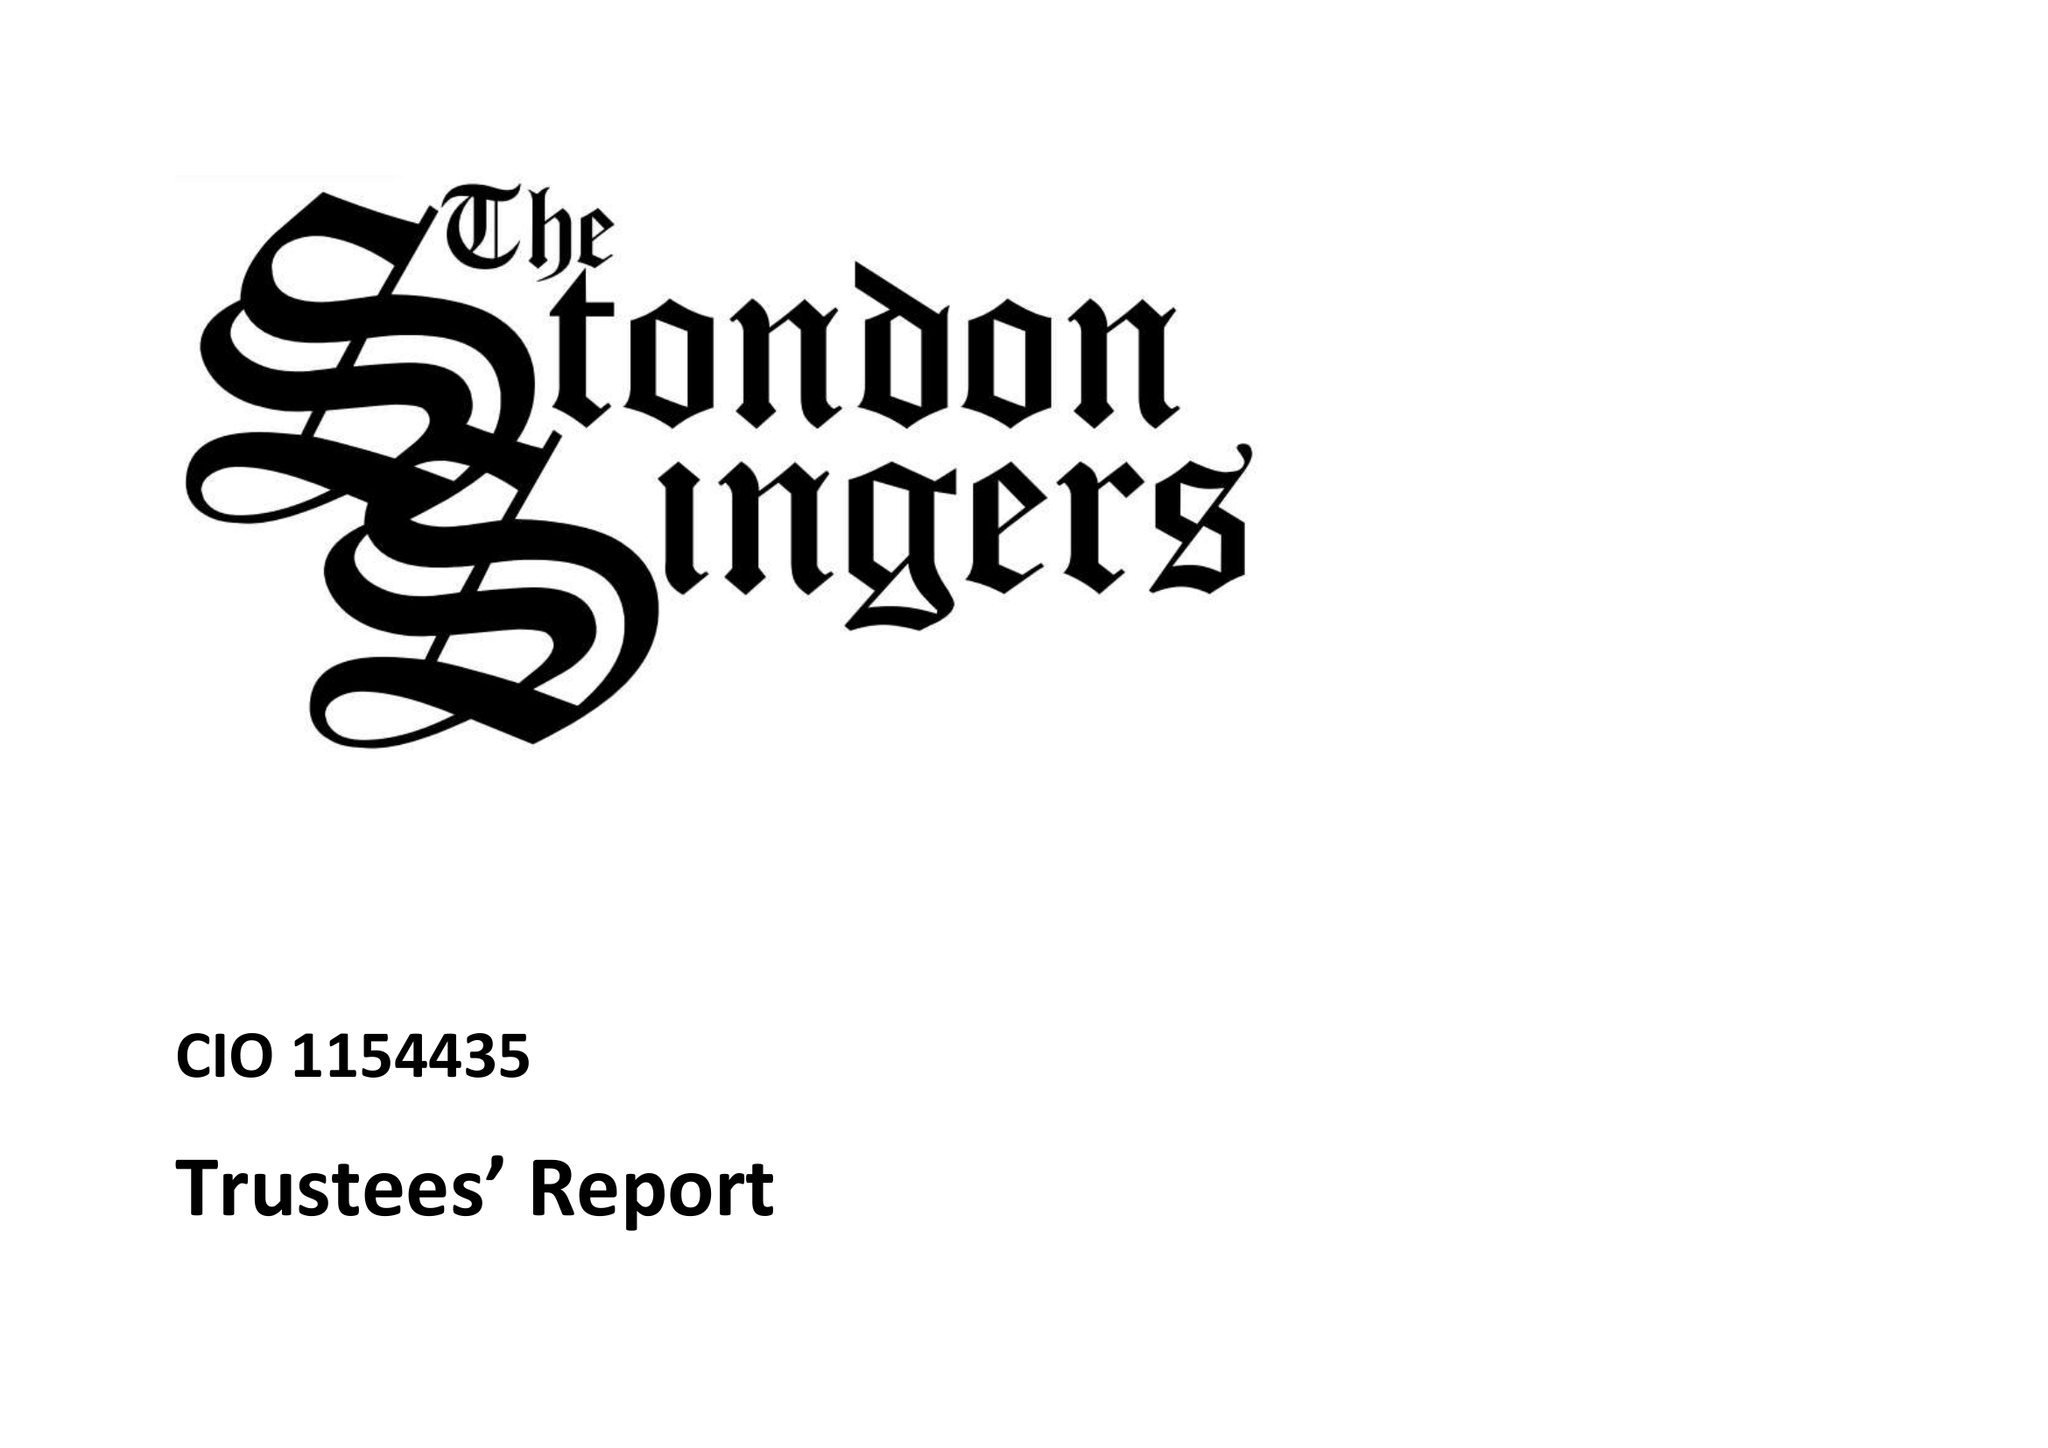What is the value for the charity_number?
Answer the question using a single word or phrase. 1154435 